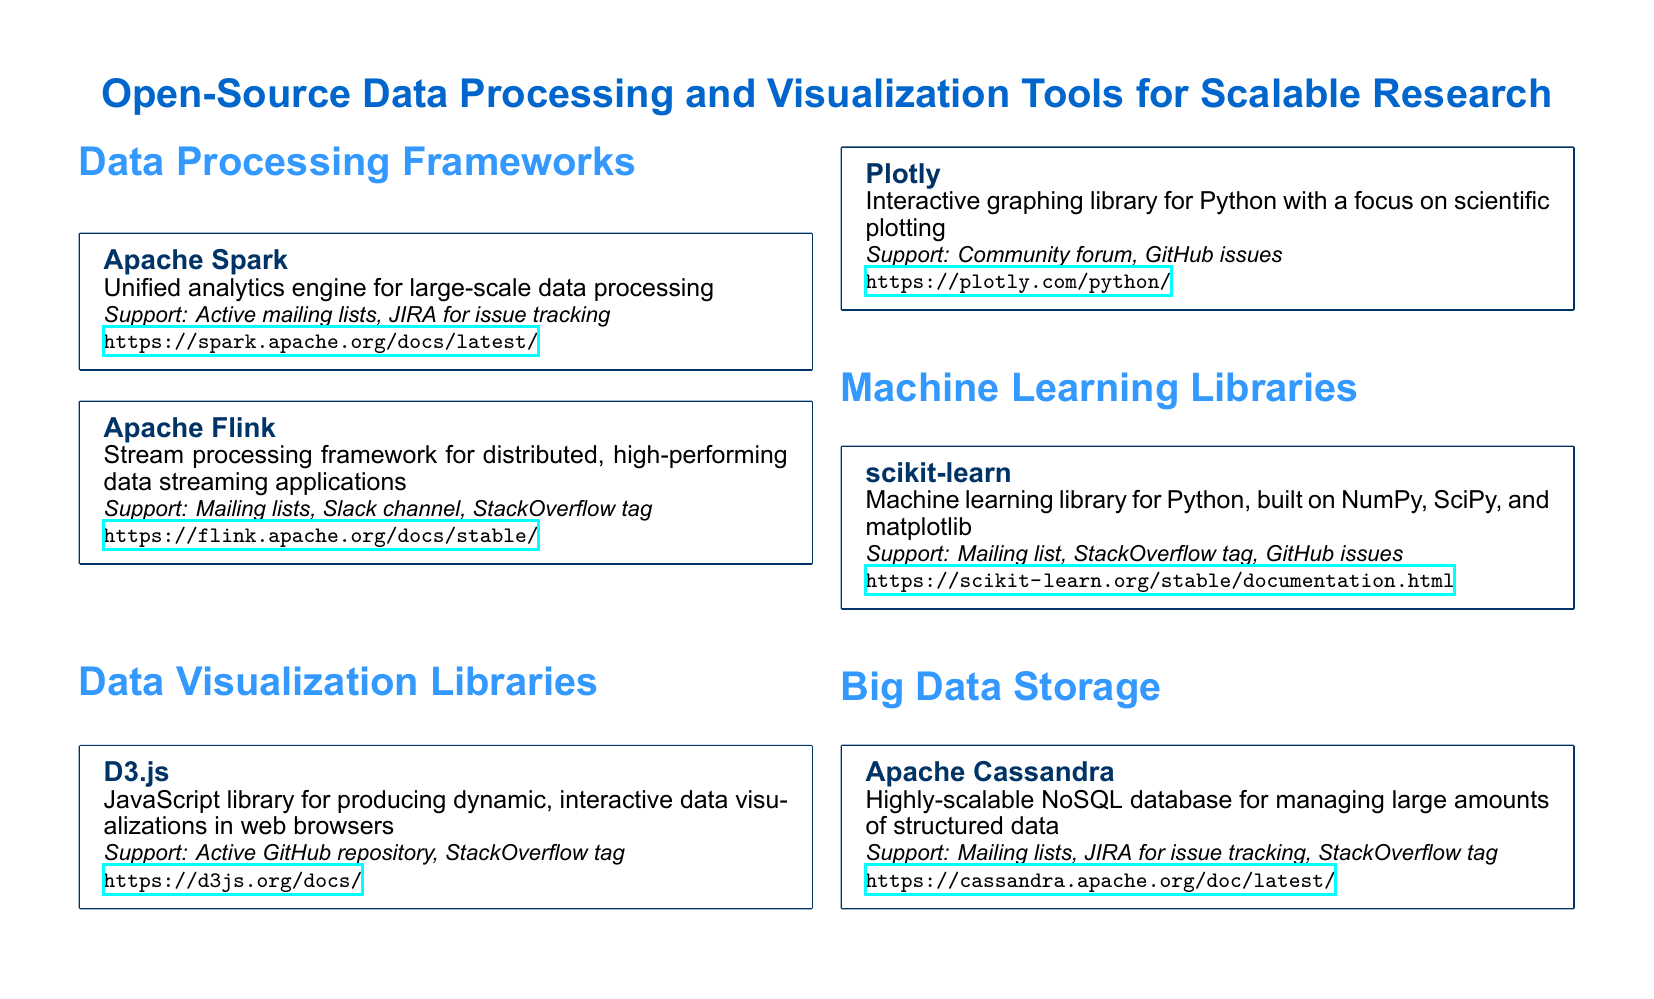What is the name of the first data processing framework listed? The first data processing framework listed in the document is Apache Spark.
Answer: Apache Spark How many data visualization libraries are included in the document? The document lists two data visualization libraries: D3.js and Plotly.
Answer: 2 What type of database is Apache Cassandra? Apache Cassandra is described as a highly-scalable NoSQL database.
Answer: NoSQL What type of support does the scikit-learn community have? The scikit-learn community offers a mailing list, StackOverflow tag, and GitHub issues for support.
Answer: Mailing list, StackOverflow tag, GitHub issues Which library is focused on scientific plotting? Plotly is noted for its focus on interactive scientific plotting.
Answer: Plotly What is the primary purpose of Apache Flink? Apache Flink is a stream processing framework for distributed high-performing data streaming applications.
Answer: Stream processing How many sections are there in the document? The document has four main sections: Data Processing Frameworks, Data Visualization Libraries, Machine Learning Libraries, and Big Data Storage.
Answer: 4 What is the URL for Apache Spark documentation? The document provides the URL https://spark.apache.org/docs/latest/ for Apache Spark documentation.
Answer: https://spark.apache.org/docs/latest/ Which JavaScript library is mentioned in the document? The document mentions D3.js as the JavaScript library for data visualizations.
Answer: D3.js 